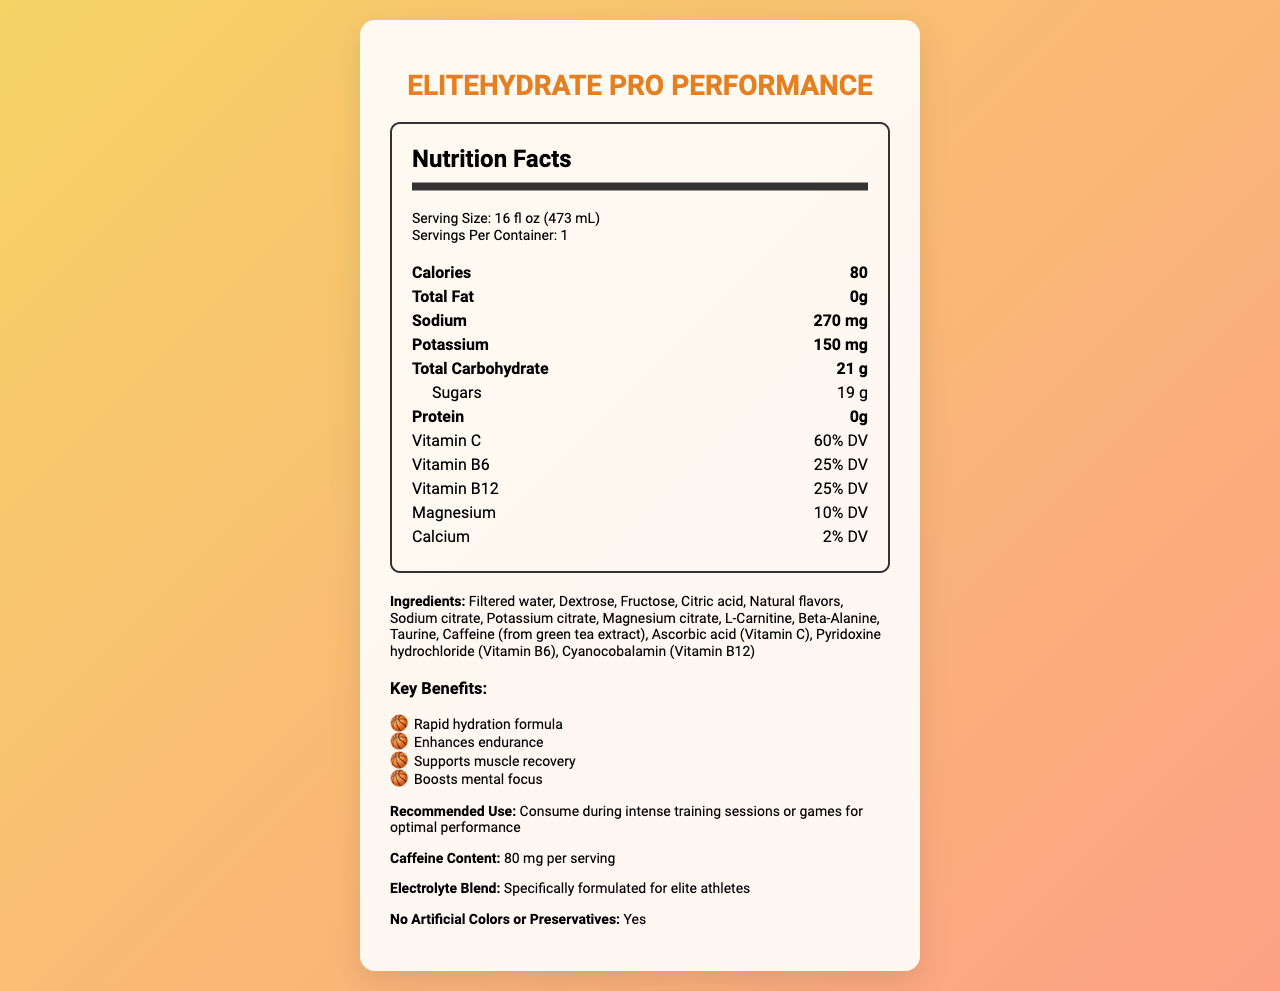what is the serving size of EliteHydrate Pro Performance? The serving size is listed directly under the nutrition facts section.
Answer: 16 fl oz (473 mL) How many servings are in one container of EliteHydrate Pro Performance? The servings per container value is 1 as stated in the nutrition facts.
Answer: 1 What is the total carbohydrate content per serving? The total carbohydrate content is specified as 21 g in the nutrition facts.
Answer: 21 g What is the sodium content in the sports drink? According to the nutrition facts, the sodium content per serving is 270 mg.
Answer: 270 mg What percentage of Vitamin C does one serving provide? The nutrition facts section states that one serving provides 60% of the daily value for Vitamin C.
Answer: 60% DV Which ingredient is listed first in EliteHydrate Pro Performance? The ingredient list starts off with filtered water.
Answer: Filtered water List all key benefits of drinking EliteHydrate Pro Performance. The document lists these four key benefits under the additional information section.
Answer: Rapid hydration formula, Enhances endurance, Supports muscle recovery, Boosts mental focus What encourages muscle recovery in this drink? "Supports muscle recovery" is explicitly mentioned as one of the key benefits.
Answer: Supports muscle recovery What is the caffeine content per serving of the sports drink? The caffeine content per serving is given as 80 mg in the additional information section.
Answer: 80 mg Does EliteHydrate Pro Performance contain artificial colors or preservatives? The drink is stated as having no artificial colors or preservatives in the additional information section.
Answer: No How many calories are in one serving? The nutrition facts list the calorie content as 80 calories per serving.
Answer: 80 Identify two vitamins present in EliteHydrate Pro Performance. The document lists both Vitamin C and Vitamin B6 in the nutrition facts section.
Answer: Vitamin C and Vitamin B6 Which of the following ingredients is NOT in EliteHydrate Pro Performance:
A. L-Carnitine
B. Taurine
C. Aspartame
D. Magnesium citrate Aspartame is not listed among the ingredients provided in the document.
Answer: C. Aspartame How much protein does a serving of this sports drink contain? The protein content listed in the nutrition facts is 0 g.
Answer: 0 g Does EliteHydrate Pro Performance support mental focus? One of the key benefits listed is that it "Boosts mental focus."
Answer: Yes Summarize the main features of EliteHydrate Pro Performance. This summary covers the product name, purpose, nutritional facts, and key features as described in the document.
Answer: EliteHydrate Pro Performance is a specialized sports drink designed for rapid hydration, endurance enhancement, muscle recovery support, and mental focus boosting. It contains 80 calories per 16 fl oz serving, with key electrolytes and vitamins such as sodium, potassium, Vitamin C, B6, and B12. It includes no artificial colors or preservatives and is intended to be consumed during intense training or games. What is the main role of L-Carnitine in this drink? The document lists L-Carnitine as an ingredient but does not specifically describe its purpose or benefits in this context.
Answer: Not enough information 